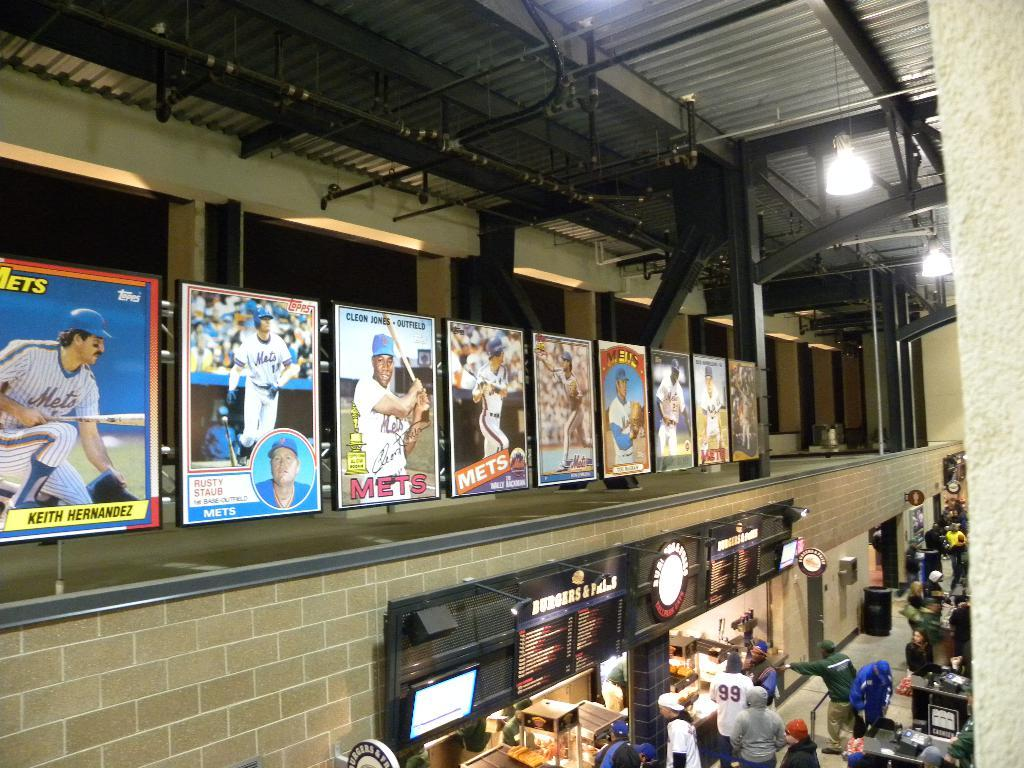<image>
Present a compact description of the photo's key features. Large posters of the Mets baseball team hang above a concession stand. 